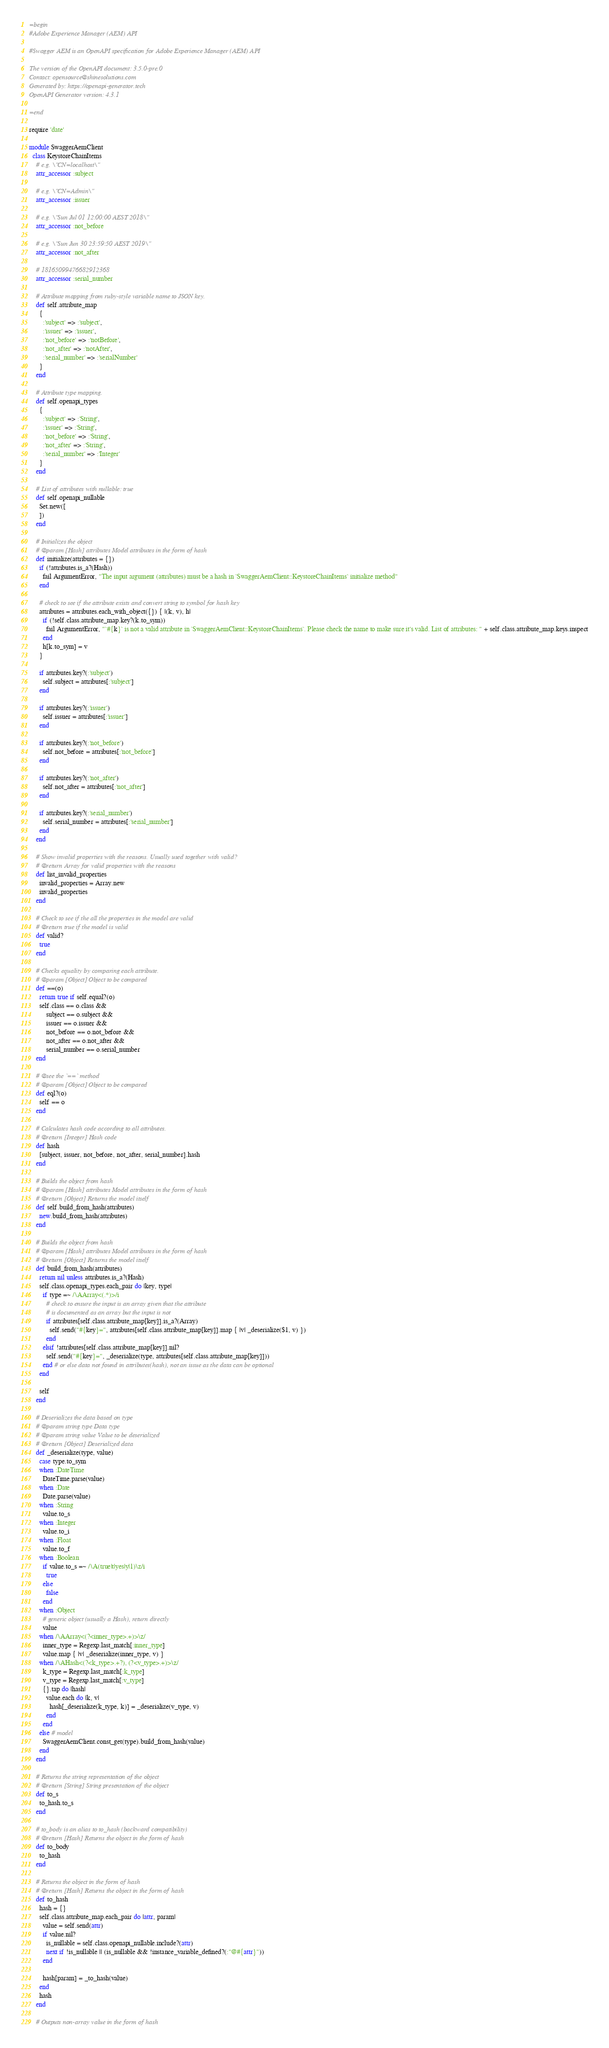<code> <loc_0><loc_0><loc_500><loc_500><_Ruby_>=begin
#Adobe Experience Manager (AEM) API

#Swagger AEM is an OpenAPI specification for Adobe Experience Manager (AEM) API

The version of the OpenAPI document: 3.5.0-pre.0
Contact: opensource@shinesolutions.com
Generated by: https://openapi-generator.tech
OpenAPI Generator version: 4.3.1

=end

require 'date'

module SwaggerAemClient
  class KeystoreChainItems
    # e.g. \"CN=localhost\"
    attr_accessor :subject

    # e.g. \"CN=Admin\"
    attr_accessor :issuer

    # e.g. \"Sun Jul 01 12:00:00 AEST 2018\"
    attr_accessor :not_before

    # e.g. \"Sun Jun 30 23:59:50 AEST 2019\"
    attr_accessor :not_after

    # 18165099476682912368
    attr_accessor :serial_number

    # Attribute mapping from ruby-style variable name to JSON key.
    def self.attribute_map
      {
        :'subject' => :'subject',
        :'issuer' => :'issuer',
        :'not_before' => :'notBefore',
        :'not_after' => :'notAfter',
        :'serial_number' => :'serialNumber'
      }
    end

    # Attribute type mapping.
    def self.openapi_types
      {
        :'subject' => :'String',
        :'issuer' => :'String',
        :'not_before' => :'String',
        :'not_after' => :'String',
        :'serial_number' => :'Integer'
      }
    end

    # List of attributes with nullable: true
    def self.openapi_nullable
      Set.new([
      ])
    end

    # Initializes the object
    # @param [Hash] attributes Model attributes in the form of hash
    def initialize(attributes = {})
      if (!attributes.is_a?(Hash))
        fail ArgumentError, "The input argument (attributes) must be a hash in `SwaggerAemClient::KeystoreChainItems` initialize method"
      end

      # check to see if the attribute exists and convert string to symbol for hash key
      attributes = attributes.each_with_object({}) { |(k, v), h|
        if (!self.class.attribute_map.key?(k.to_sym))
          fail ArgumentError, "`#{k}` is not a valid attribute in `SwaggerAemClient::KeystoreChainItems`. Please check the name to make sure it's valid. List of attributes: " + self.class.attribute_map.keys.inspect
        end
        h[k.to_sym] = v
      }

      if attributes.key?(:'subject')
        self.subject = attributes[:'subject']
      end

      if attributes.key?(:'issuer')
        self.issuer = attributes[:'issuer']
      end

      if attributes.key?(:'not_before')
        self.not_before = attributes[:'not_before']
      end

      if attributes.key?(:'not_after')
        self.not_after = attributes[:'not_after']
      end

      if attributes.key?(:'serial_number')
        self.serial_number = attributes[:'serial_number']
      end
    end

    # Show invalid properties with the reasons. Usually used together with valid?
    # @return Array for valid properties with the reasons
    def list_invalid_properties
      invalid_properties = Array.new
      invalid_properties
    end

    # Check to see if the all the properties in the model are valid
    # @return true if the model is valid
    def valid?
      true
    end

    # Checks equality by comparing each attribute.
    # @param [Object] Object to be compared
    def ==(o)
      return true if self.equal?(o)
      self.class == o.class &&
          subject == o.subject &&
          issuer == o.issuer &&
          not_before == o.not_before &&
          not_after == o.not_after &&
          serial_number == o.serial_number
    end

    # @see the `==` method
    # @param [Object] Object to be compared
    def eql?(o)
      self == o
    end

    # Calculates hash code according to all attributes.
    # @return [Integer] Hash code
    def hash
      [subject, issuer, not_before, not_after, serial_number].hash
    end

    # Builds the object from hash
    # @param [Hash] attributes Model attributes in the form of hash
    # @return [Object] Returns the model itself
    def self.build_from_hash(attributes)
      new.build_from_hash(attributes)
    end

    # Builds the object from hash
    # @param [Hash] attributes Model attributes in the form of hash
    # @return [Object] Returns the model itself
    def build_from_hash(attributes)
      return nil unless attributes.is_a?(Hash)
      self.class.openapi_types.each_pair do |key, type|
        if type =~ /\AArray<(.*)>/i
          # check to ensure the input is an array given that the attribute
          # is documented as an array but the input is not
          if attributes[self.class.attribute_map[key]].is_a?(Array)
            self.send("#{key}=", attributes[self.class.attribute_map[key]].map { |v| _deserialize($1, v) })
          end
        elsif !attributes[self.class.attribute_map[key]].nil?
          self.send("#{key}=", _deserialize(type, attributes[self.class.attribute_map[key]]))
        end # or else data not found in attributes(hash), not an issue as the data can be optional
      end

      self
    end

    # Deserializes the data based on type
    # @param string type Data type
    # @param string value Value to be deserialized
    # @return [Object] Deserialized data
    def _deserialize(type, value)
      case type.to_sym
      when :DateTime
        DateTime.parse(value)
      when :Date
        Date.parse(value)
      when :String
        value.to_s
      when :Integer
        value.to_i
      when :Float
        value.to_f
      when :Boolean
        if value.to_s =~ /\A(true|t|yes|y|1)\z/i
          true
        else
          false
        end
      when :Object
        # generic object (usually a Hash), return directly
        value
      when /\AArray<(?<inner_type>.+)>\z/
        inner_type = Regexp.last_match[:inner_type]
        value.map { |v| _deserialize(inner_type, v) }
      when /\AHash<(?<k_type>.+?), (?<v_type>.+)>\z/
        k_type = Regexp.last_match[:k_type]
        v_type = Regexp.last_match[:v_type]
        {}.tap do |hash|
          value.each do |k, v|
            hash[_deserialize(k_type, k)] = _deserialize(v_type, v)
          end
        end
      else # model
        SwaggerAemClient.const_get(type).build_from_hash(value)
      end
    end

    # Returns the string representation of the object
    # @return [String] String presentation of the object
    def to_s
      to_hash.to_s
    end

    # to_body is an alias to to_hash (backward compatibility)
    # @return [Hash] Returns the object in the form of hash
    def to_body
      to_hash
    end

    # Returns the object in the form of hash
    # @return [Hash] Returns the object in the form of hash
    def to_hash
      hash = {}
      self.class.attribute_map.each_pair do |attr, param|
        value = self.send(attr)
        if value.nil?
          is_nullable = self.class.openapi_nullable.include?(attr)
          next if !is_nullable || (is_nullable && !instance_variable_defined?(:"@#{attr}"))
        end
        
        hash[param] = _to_hash(value)
      end
      hash
    end

    # Outputs non-array value in the form of hash</code> 